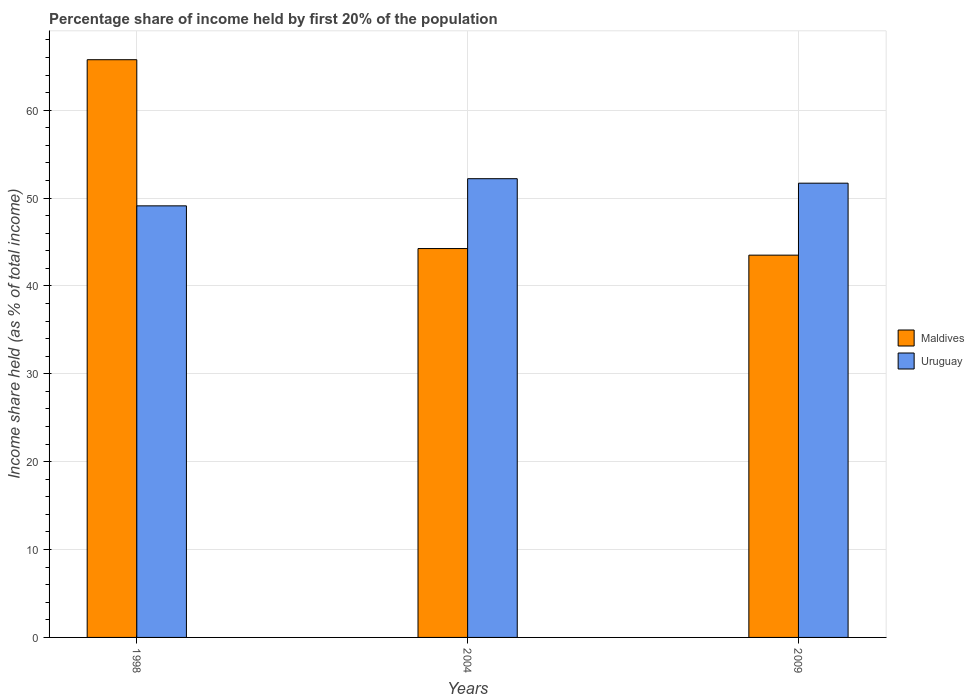How many different coloured bars are there?
Provide a succinct answer. 2. How many groups of bars are there?
Keep it short and to the point. 3. Are the number of bars per tick equal to the number of legend labels?
Provide a succinct answer. Yes. How many bars are there on the 1st tick from the right?
Give a very brief answer. 2. What is the label of the 3rd group of bars from the left?
Provide a succinct answer. 2009. What is the share of income held by first 20% of the population in Maldives in 1998?
Provide a short and direct response. 65.74. Across all years, what is the maximum share of income held by first 20% of the population in Uruguay?
Make the answer very short. 52.2. Across all years, what is the minimum share of income held by first 20% of the population in Maldives?
Your answer should be very brief. 43.5. In which year was the share of income held by first 20% of the population in Maldives maximum?
Your response must be concise. 1998. What is the total share of income held by first 20% of the population in Maldives in the graph?
Your answer should be compact. 153.49. What is the difference between the share of income held by first 20% of the population in Uruguay in 2004 and that in 2009?
Your answer should be compact. 0.51. What is the difference between the share of income held by first 20% of the population in Maldives in 1998 and the share of income held by first 20% of the population in Uruguay in 2004?
Your answer should be compact. 13.54. What is the average share of income held by first 20% of the population in Uruguay per year?
Offer a terse response. 51. In the year 2004, what is the difference between the share of income held by first 20% of the population in Uruguay and share of income held by first 20% of the population in Maldives?
Give a very brief answer. 7.95. In how many years, is the share of income held by first 20% of the population in Maldives greater than 32 %?
Offer a very short reply. 3. What is the ratio of the share of income held by first 20% of the population in Maldives in 1998 to that in 2009?
Offer a very short reply. 1.51. Is the difference between the share of income held by first 20% of the population in Uruguay in 1998 and 2004 greater than the difference between the share of income held by first 20% of the population in Maldives in 1998 and 2004?
Make the answer very short. No. What is the difference between the highest and the second highest share of income held by first 20% of the population in Uruguay?
Your answer should be very brief. 0.51. What is the difference between the highest and the lowest share of income held by first 20% of the population in Uruguay?
Make the answer very short. 3.09. In how many years, is the share of income held by first 20% of the population in Uruguay greater than the average share of income held by first 20% of the population in Uruguay taken over all years?
Make the answer very short. 2. What does the 2nd bar from the left in 2009 represents?
Keep it short and to the point. Uruguay. What does the 1st bar from the right in 2004 represents?
Offer a very short reply. Uruguay. How many years are there in the graph?
Your answer should be very brief. 3. What is the difference between two consecutive major ticks on the Y-axis?
Provide a short and direct response. 10. Are the values on the major ticks of Y-axis written in scientific E-notation?
Provide a short and direct response. No. Does the graph contain any zero values?
Ensure brevity in your answer.  No. Where does the legend appear in the graph?
Make the answer very short. Center right. How are the legend labels stacked?
Offer a terse response. Vertical. What is the title of the graph?
Offer a terse response. Percentage share of income held by first 20% of the population. Does "Lesotho" appear as one of the legend labels in the graph?
Your response must be concise. No. What is the label or title of the Y-axis?
Ensure brevity in your answer.  Income share held (as % of total income). What is the Income share held (as % of total income) of Maldives in 1998?
Give a very brief answer. 65.74. What is the Income share held (as % of total income) of Uruguay in 1998?
Provide a succinct answer. 49.11. What is the Income share held (as % of total income) in Maldives in 2004?
Provide a succinct answer. 44.25. What is the Income share held (as % of total income) in Uruguay in 2004?
Give a very brief answer. 52.2. What is the Income share held (as % of total income) in Maldives in 2009?
Offer a terse response. 43.5. What is the Income share held (as % of total income) of Uruguay in 2009?
Your answer should be very brief. 51.69. Across all years, what is the maximum Income share held (as % of total income) in Maldives?
Give a very brief answer. 65.74. Across all years, what is the maximum Income share held (as % of total income) in Uruguay?
Make the answer very short. 52.2. Across all years, what is the minimum Income share held (as % of total income) in Maldives?
Make the answer very short. 43.5. Across all years, what is the minimum Income share held (as % of total income) of Uruguay?
Provide a succinct answer. 49.11. What is the total Income share held (as % of total income) of Maldives in the graph?
Make the answer very short. 153.49. What is the total Income share held (as % of total income) in Uruguay in the graph?
Ensure brevity in your answer.  153. What is the difference between the Income share held (as % of total income) of Maldives in 1998 and that in 2004?
Ensure brevity in your answer.  21.49. What is the difference between the Income share held (as % of total income) in Uruguay in 1998 and that in 2004?
Offer a very short reply. -3.09. What is the difference between the Income share held (as % of total income) of Maldives in 1998 and that in 2009?
Offer a terse response. 22.24. What is the difference between the Income share held (as % of total income) in Uruguay in 1998 and that in 2009?
Make the answer very short. -2.58. What is the difference between the Income share held (as % of total income) in Uruguay in 2004 and that in 2009?
Give a very brief answer. 0.51. What is the difference between the Income share held (as % of total income) of Maldives in 1998 and the Income share held (as % of total income) of Uruguay in 2004?
Provide a short and direct response. 13.54. What is the difference between the Income share held (as % of total income) of Maldives in 1998 and the Income share held (as % of total income) of Uruguay in 2009?
Your response must be concise. 14.05. What is the difference between the Income share held (as % of total income) in Maldives in 2004 and the Income share held (as % of total income) in Uruguay in 2009?
Your answer should be very brief. -7.44. What is the average Income share held (as % of total income) in Maldives per year?
Your answer should be very brief. 51.16. What is the average Income share held (as % of total income) of Uruguay per year?
Your answer should be very brief. 51. In the year 1998, what is the difference between the Income share held (as % of total income) of Maldives and Income share held (as % of total income) of Uruguay?
Provide a short and direct response. 16.63. In the year 2004, what is the difference between the Income share held (as % of total income) in Maldives and Income share held (as % of total income) in Uruguay?
Ensure brevity in your answer.  -7.95. In the year 2009, what is the difference between the Income share held (as % of total income) of Maldives and Income share held (as % of total income) of Uruguay?
Your answer should be very brief. -8.19. What is the ratio of the Income share held (as % of total income) of Maldives in 1998 to that in 2004?
Offer a very short reply. 1.49. What is the ratio of the Income share held (as % of total income) of Uruguay in 1998 to that in 2004?
Your answer should be compact. 0.94. What is the ratio of the Income share held (as % of total income) of Maldives in 1998 to that in 2009?
Make the answer very short. 1.51. What is the ratio of the Income share held (as % of total income) in Uruguay in 1998 to that in 2009?
Provide a succinct answer. 0.95. What is the ratio of the Income share held (as % of total income) of Maldives in 2004 to that in 2009?
Ensure brevity in your answer.  1.02. What is the ratio of the Income share held (as % of total income) of Uruguay in 2004 to that in 2009?
Make the answer very short. 1.01. What is the difference between the highest and the second highest Income share held (as % of total income) in Maldives?
Your answer should be very brief. 21.49. What is the difference between the highest and the second highest Income share held (as % of total income) in Uruguay?
Provide a succinct answer. 0.51. What is the difference between the highest and the lowest Income share held (as % of total income) in Maldives?
Make the answer very short. 22.24. What is the difference between the highest and the lowest Income share held (as % of total income) of Uruguay?
Your response must be concise. 3.09. 